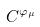Convert formula to latex. <formula><loc_0><loc_0><loc_500><loc_500>C ^ { \varphi _ { \mu } }</formula> 